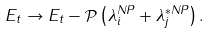<formula> <loc_0><loc_0><loc_500><loc_500>E _ { t } \rightarrow E _ { t } - \mathcal { P } \left ( \lambda _ { i } ^ { N P } + \lambda _ { j } ^ { * N P } \right ) .</formula> 